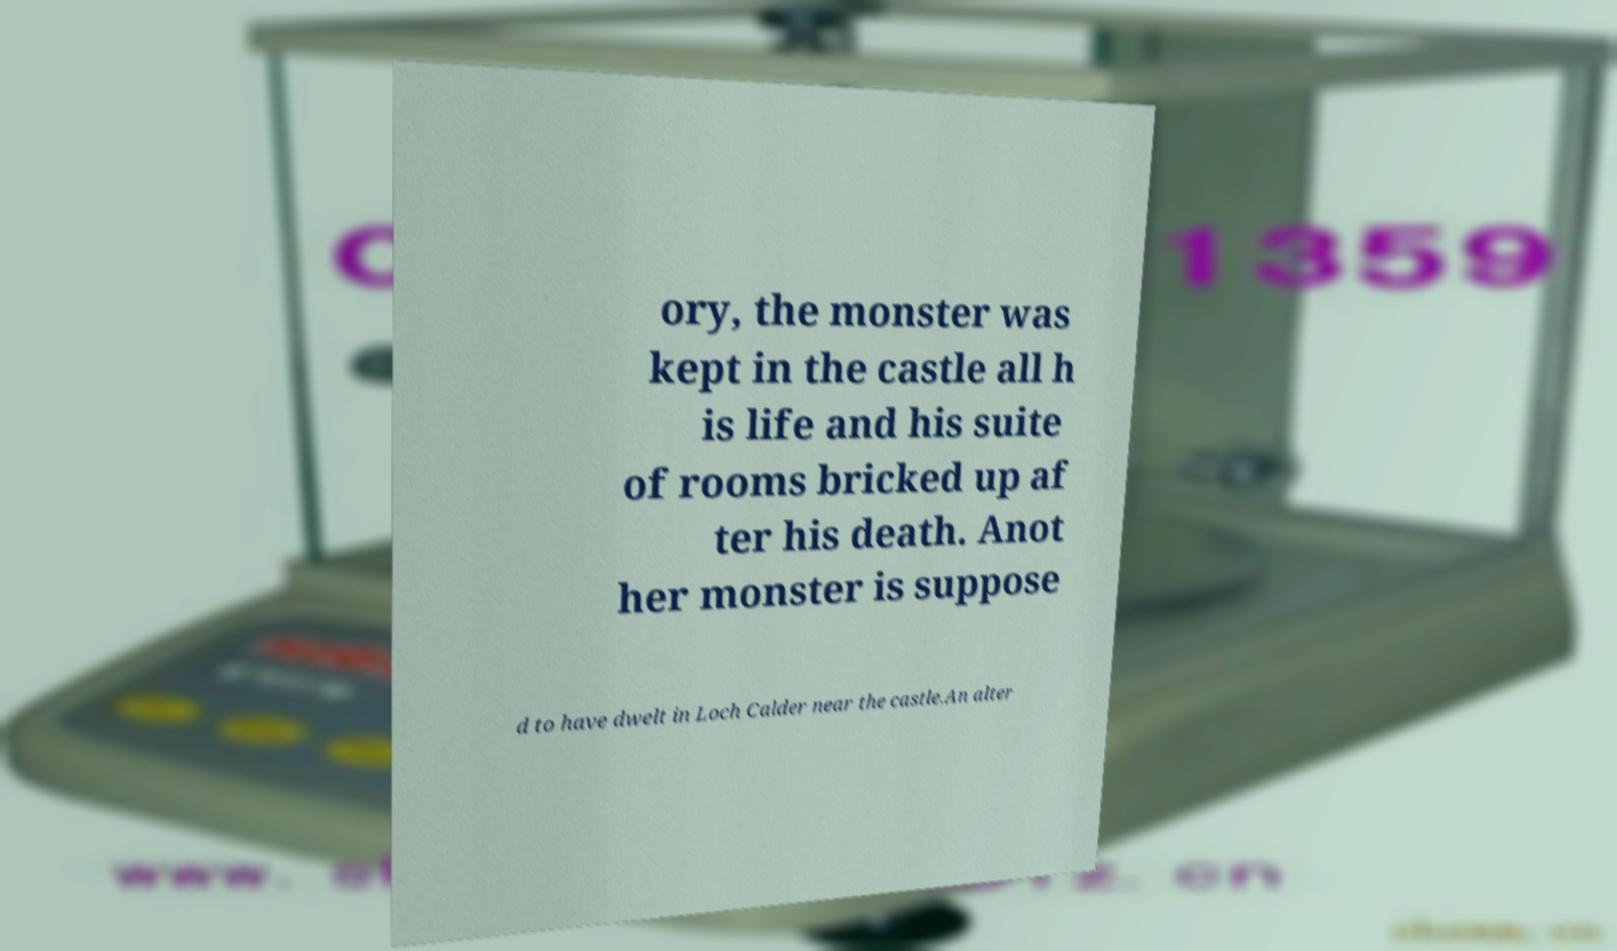I need the written content from this picture converted into text. Can you do that? ory, the monster was kept in the castle all h is life and his suite of rooms bricked up af ter his death. Anot her monster is suppose d to have dwelt in Loch Calder near the castle.An alter 